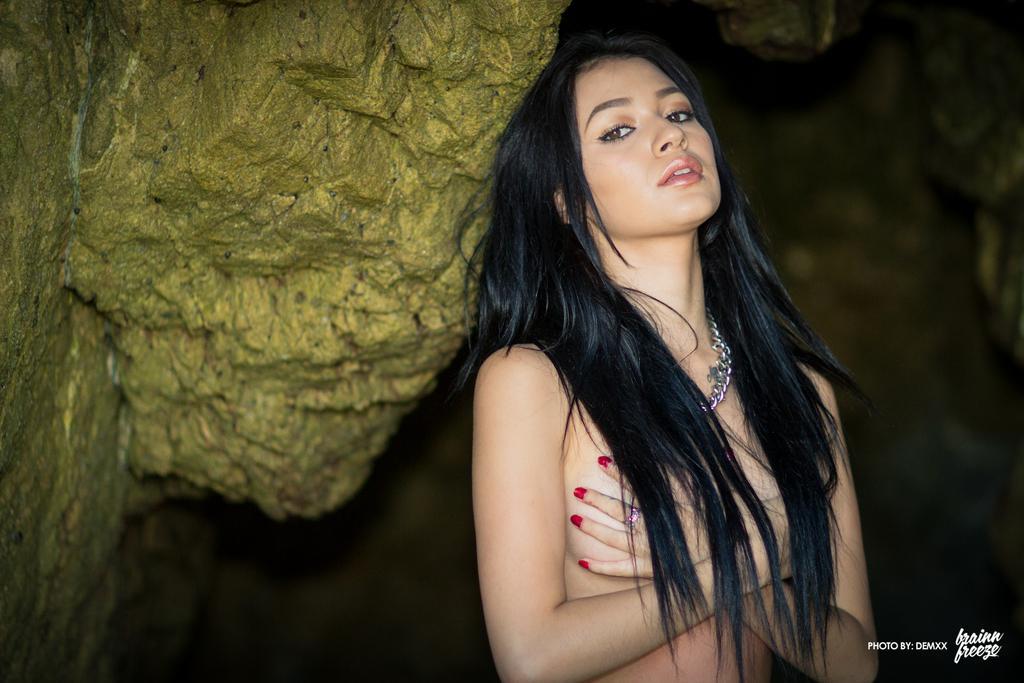Could you give a brief overview of what you see in this image? In this image I can see a woman wearing chain to her neck. I can see a rock which is yellow and green in color and the dark background. 